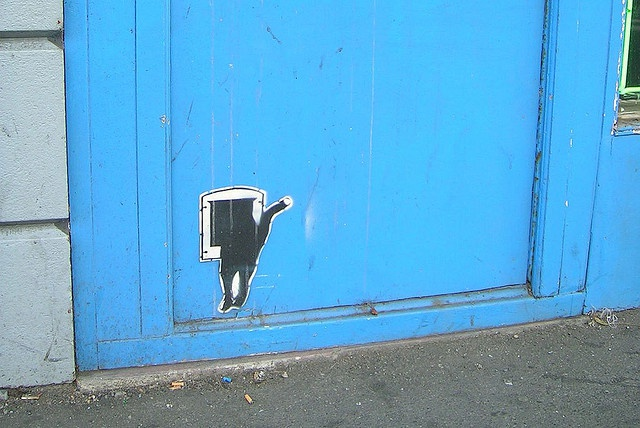Describe the objects in this image and their specific colors. I can see a cat in darkgray, purple, white, and black tones in this image. 